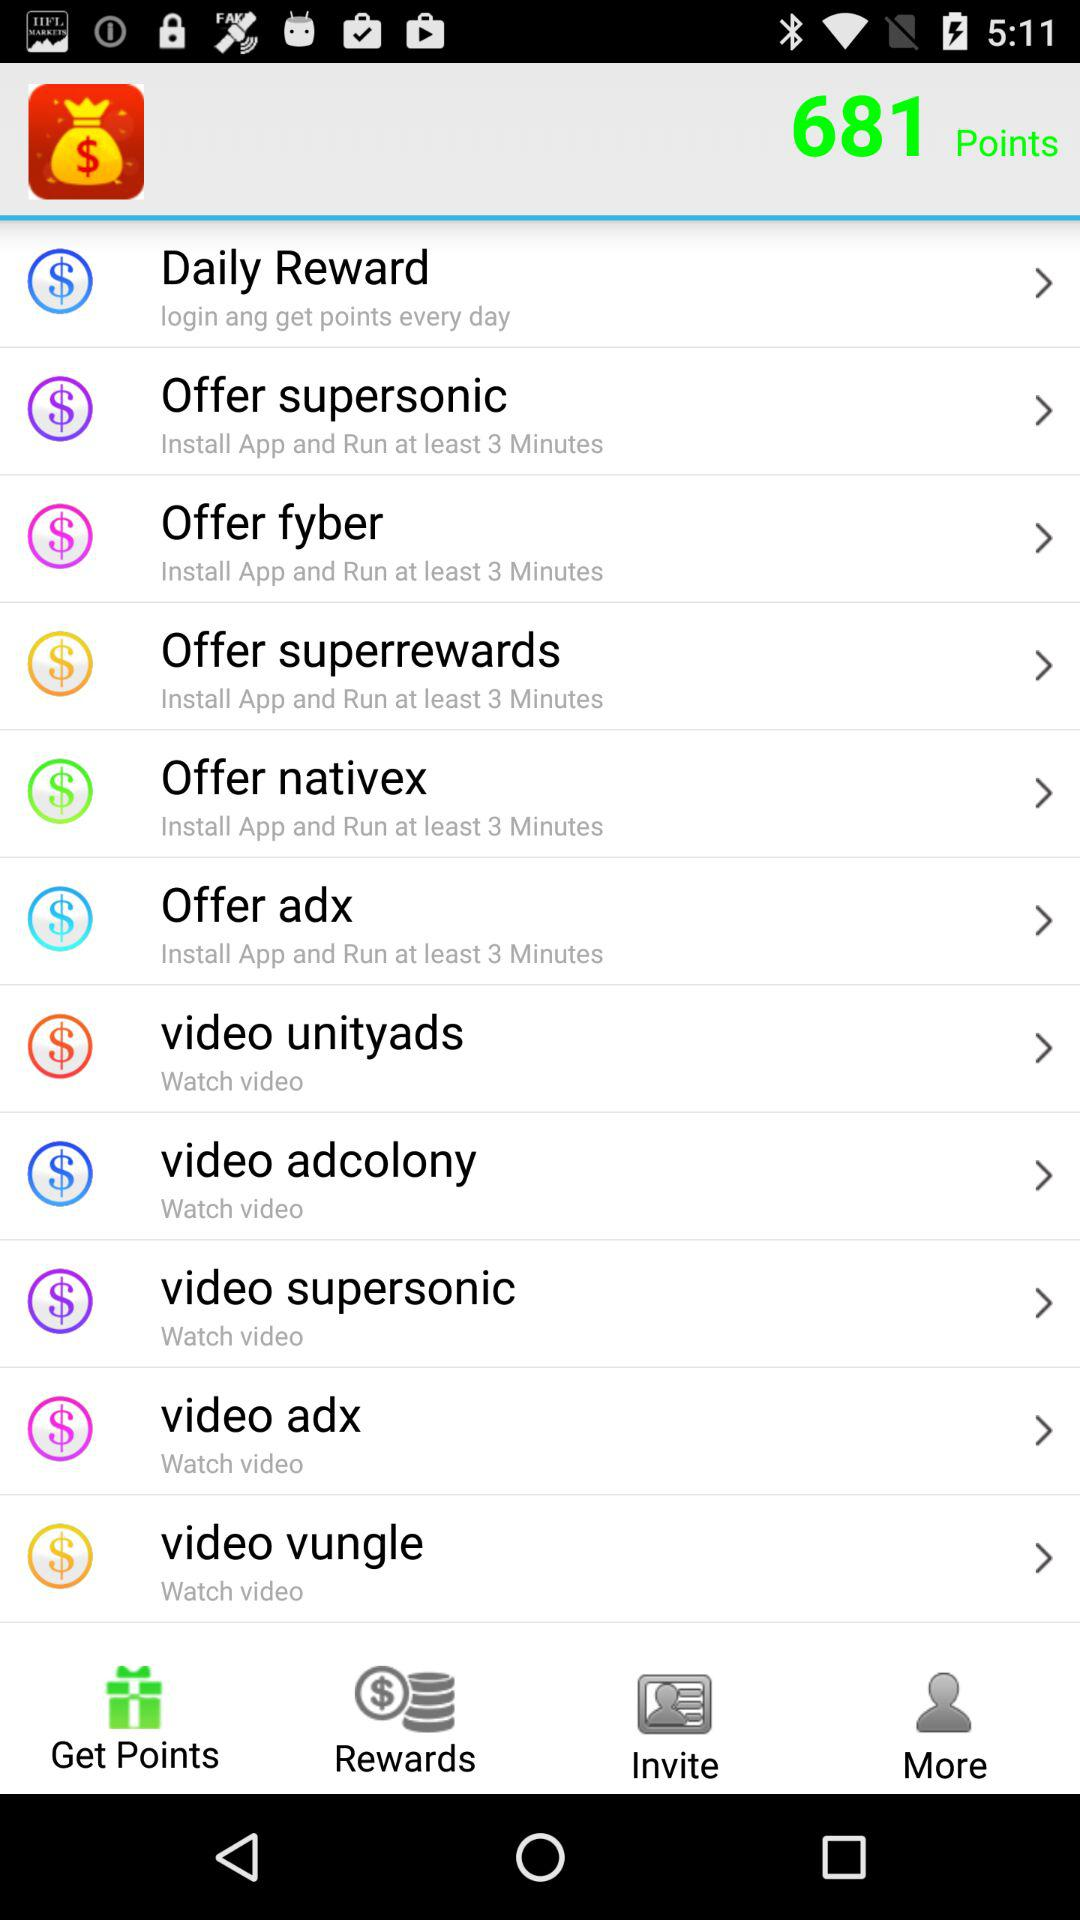How many points in total are there? There are 681 points in total. 